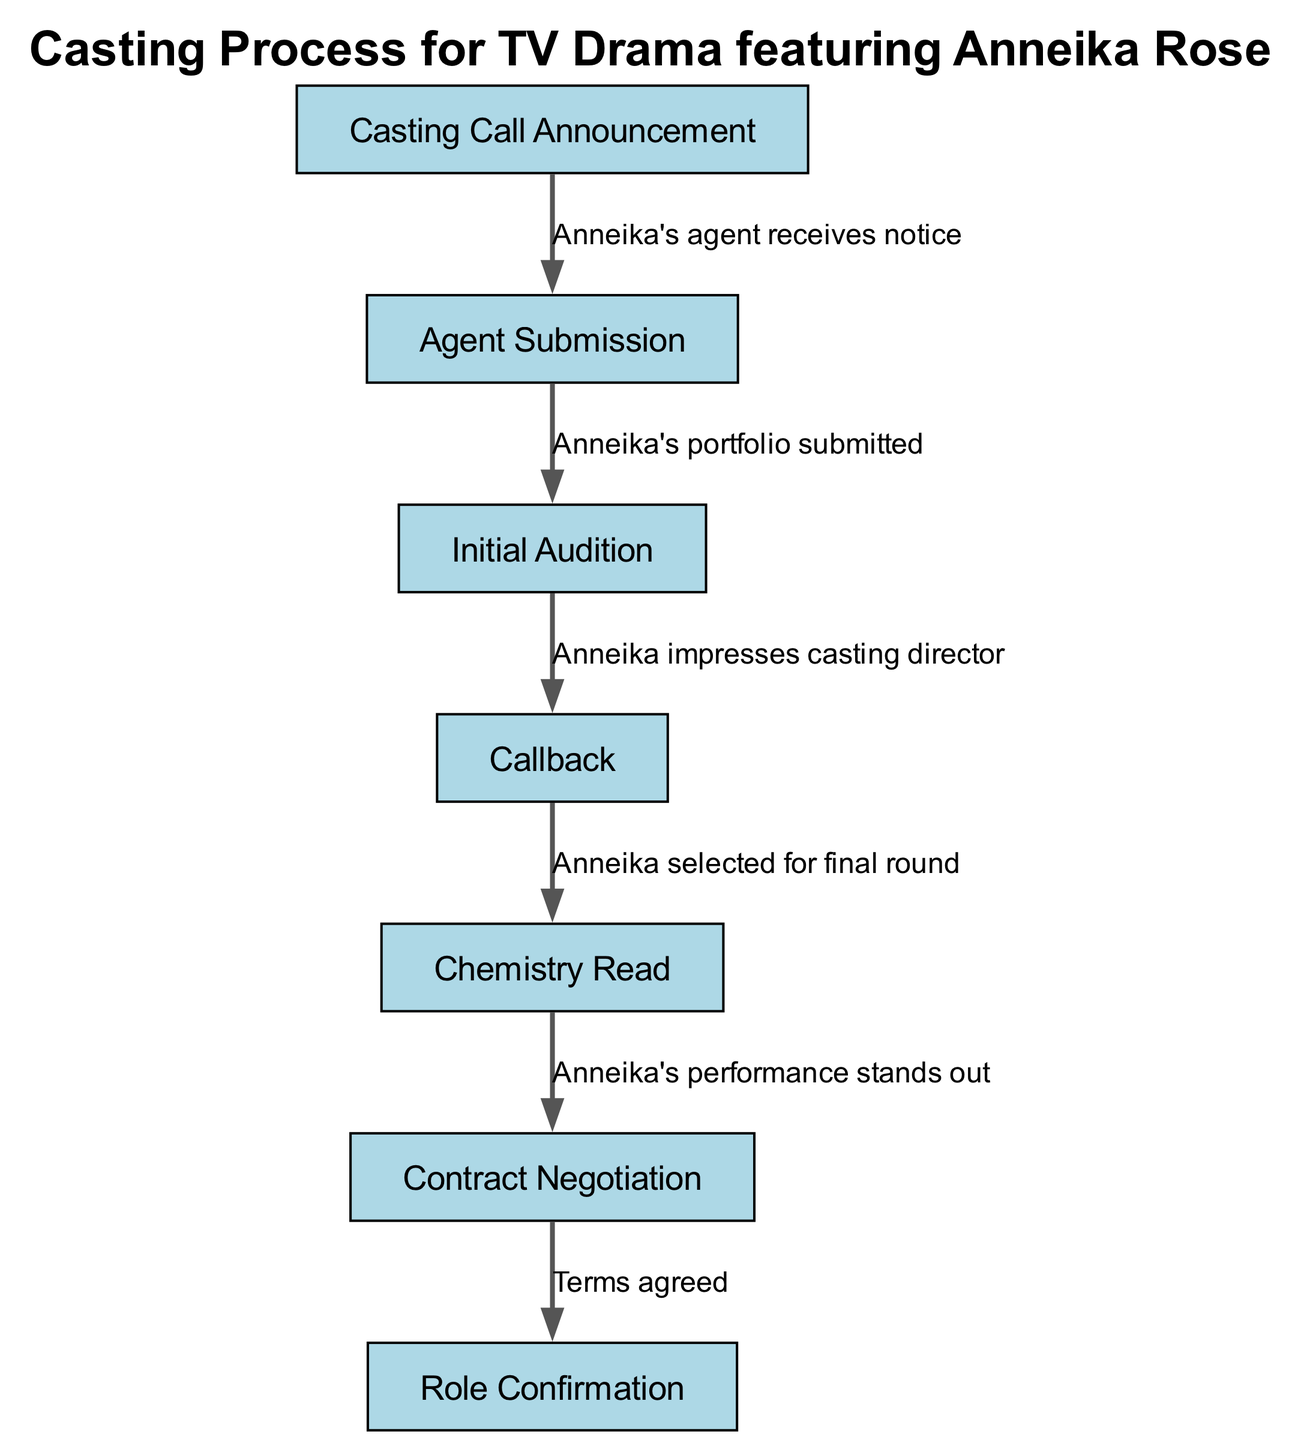What is the first step in the casting process? The first step in the casting process according to the diagram is the "Casting Call Announcement."
Answer: Casting Call Announcement How many nodes are present in the casting process diagram? The diagram shows a total of seven nodes: Casting Call Announcement, Agent Submission, Initial Audition, Callback, Chemistry Read, Contract Negotiation, and Role Confirmation.
Answer: 7 What does Anneika's agent do in step two? In step two, Anneika's agent submits her portfolio for consideration in the casting process.
Answer: Portfolio submitted What is the relationship between the "Chemistry Read" and "Contract Negotiation"? The diagram shows that after the "Chemistry Read," the next step is "Contract Negotiation," indicating that they occur sequentially in the casting process.
Answer: Sequential steps How does Anneika stand out in the casting process? Anneika stands out in the casting process during the "Chemistry Read," where her performance is noted as exceptional, thus advancing her in the process.
Answer: Performance stands out What label describes the transition from "Initial Audition" to "Callback"? The transition from "Initial Audition" to "Callback" is labeled as "Anneika impresses casting director," indicating her successful performance in the audition.
Answer: Anneika impresses casting director What is the final step of the casting process? The final step of the casting process in the diagram is "Role Confirmation," which occurs after the contract negotiation is concluded successfully.
Answer: Role Confirmation What is the outcome of the contract negotiation phase? The outcome of the contract negotiation phase is that the terms are agreed upon, leading to the confirmation of the role.
Answer: Terms agreed 